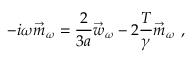Convert formula to latex. <formula><loc_0><loc_0><loc_500><loc_500>- i \omega \vec { m } _ { \omega } = \frac { 2 } { 3 a } \vec { w } _ { \omega } - 2 \frac { T } { \gamma } \vec { m } _ { \omega } \ ,</formula> 